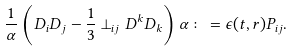Convert formula to latex. <formula><loc_0><loc_0><loc_500><loc_500>\frac { 1 } { \alpha } \left ( D _ { i } D _ { j } - \frac { 1 } { 3 } \perp _ { i j } D ^ { k } D _ { k } \right ) \alpha \colon = \epsilon ( t , r ) P _ { i j } .</formula> 